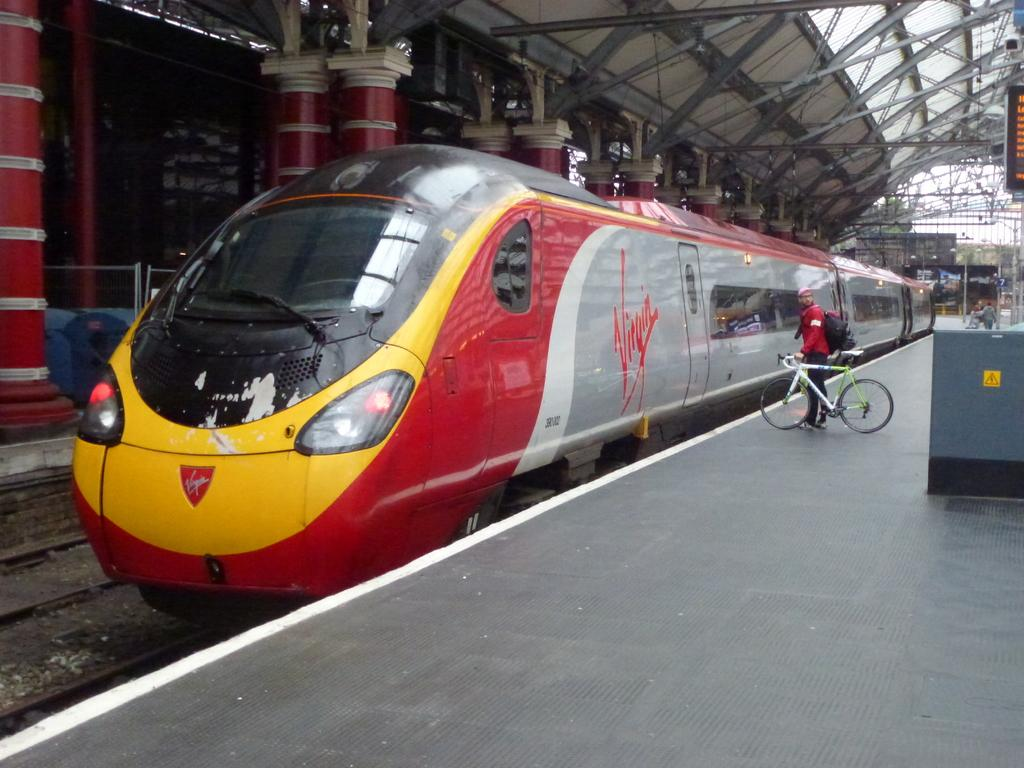<image>
Render a clear and concise summary of the photo. A train that says Virgin on it is stopped at a station. 